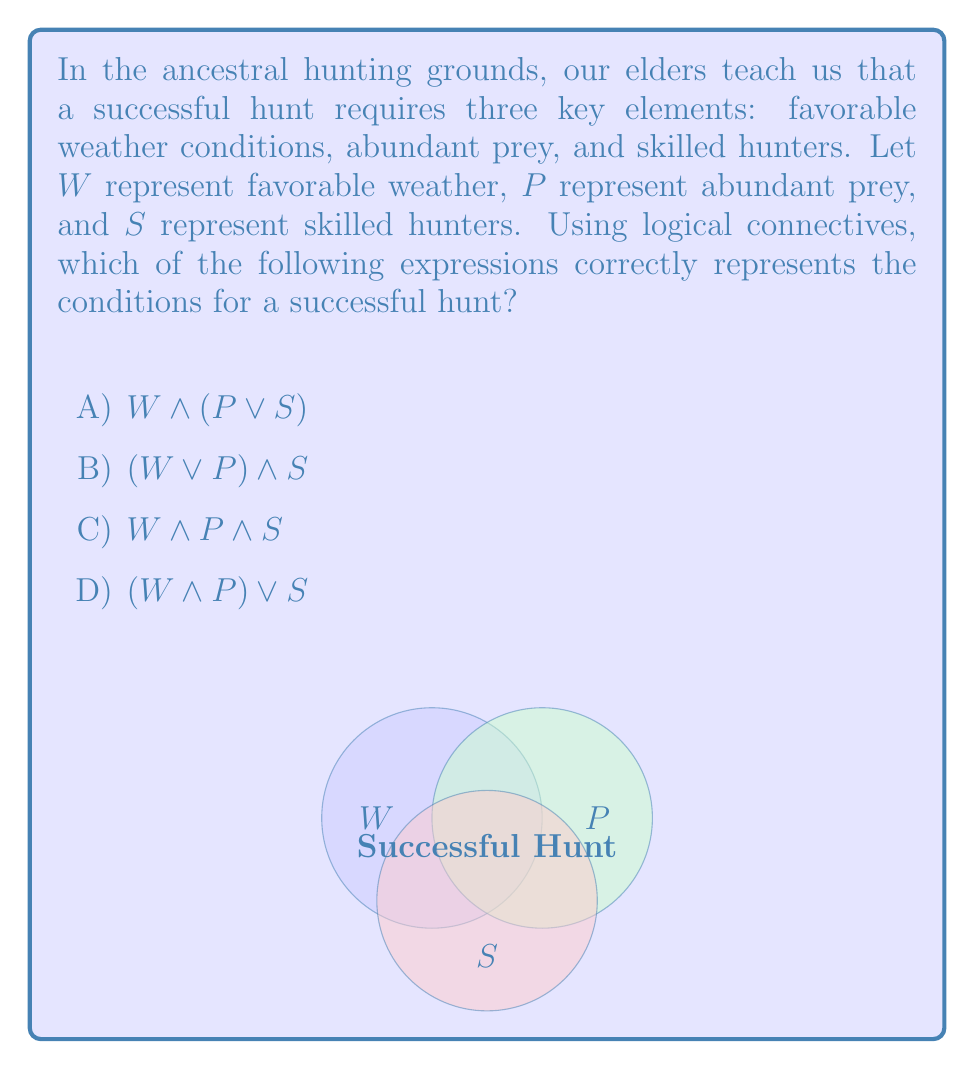Can you answer this question? Let's analyze this problem step-by-step:

1) First, we need to understand what the question is asking. We're looking for the logical expression that correctly represents all three conditions being necessary for a successful hunt.

2) Let's examine each option:

   A) $W \land (P \lor S)$: This means favorable weather AND (abundant prey OR skilled hunters). This is incorrect because it suggests that either abundant prey or skilled hunters alone (with favorable weather) is sufficient.

   B) $(W \lor P) \land S$: This means (favorable weather OR abundant prey) AND skilled hunters. This is also incorrect as it suggests that either favorable weather or abundant prey (with skilled hunters) is sufficient.

   C) $W \land P \land S$: This means favorable weather AND abundant prey AND skilled hunters. This correctly represents that all three conditions are necessary.

   D) $(W \land P) \lor S$: This means (favorable weather AND abundant prey) OR skilled hunters. This is incorrect as it suggests that skilled hunters alone can ensure a successful hunt without the other conditions.

3) The Venn diagram in the question visually represents option C, where the successful hunt occurs only in the intersection of all three circles (conditions).

4) In the context of our ancestral hunting wisdom, we understand that all three elements are crucial. The weather must be favorable to track and pursue prey, there must be abundant prey to hunt, and the hunters must be skilled to successfully capture the prey.

5) Therefore, the correct logical expression is $W \land P \land S$, which represents that all three conditions must be met simultaneously for a successful hunt.
Answer: C) $W \land P \land S$ 